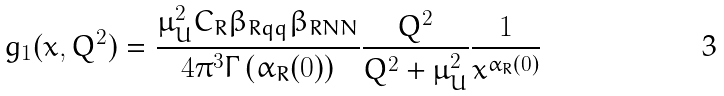Convert formula to latex. <formula><loc_0><loc_0><loc_500><loc_500>g _ { 1 } ( x , Q ^ { 2 } ) = \frac { \mu _ { U } ^ { 2 } C _ { R } \beta _ { R q q } \beta _ { R N N } } { 4 \pi ^ { 3 } \Gamma \left ( \alpha _ { R } ( 0 ) \right ) } \frac { Q ^ { 2 } } { Q ^ { 2 } + \mu _ { U } ^ { 2 } } \frac { 1 } { x ^ { \alpha _ { R } ( 0 ) } }</formula> 